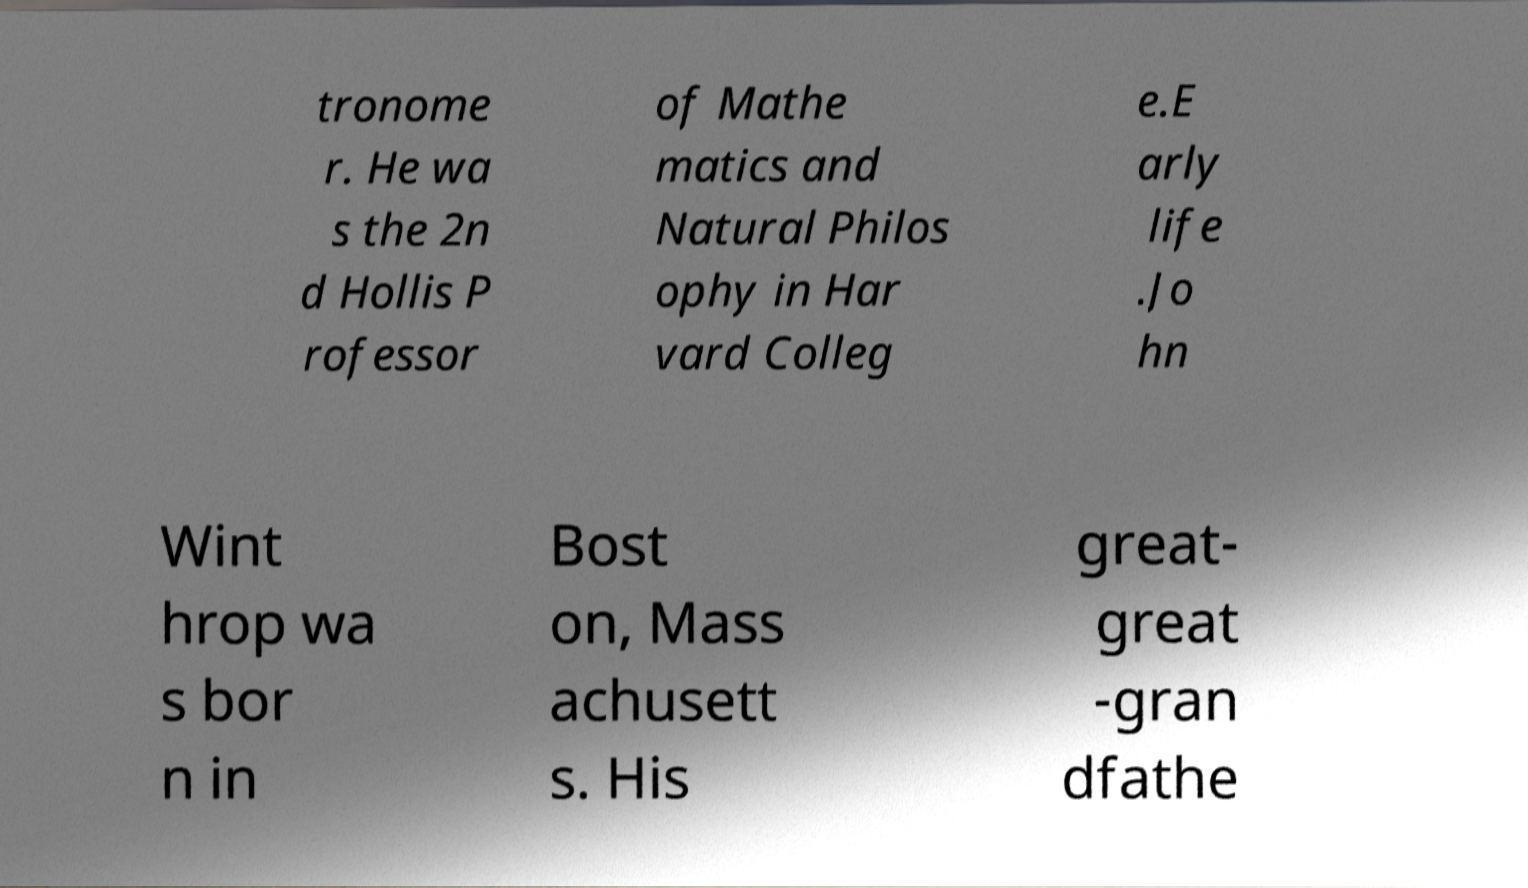Please read and relay the text visible in this image. What does it say? tronome r. He wa s the 2n d Hollis P rofessor of Mathe matics and Natural Philos ophy in Har vard Colleg e.E arly life .Jo hn Wint hrop wa s bor n in Bost on, Mass achusett s. His great- great -gran dfathe 